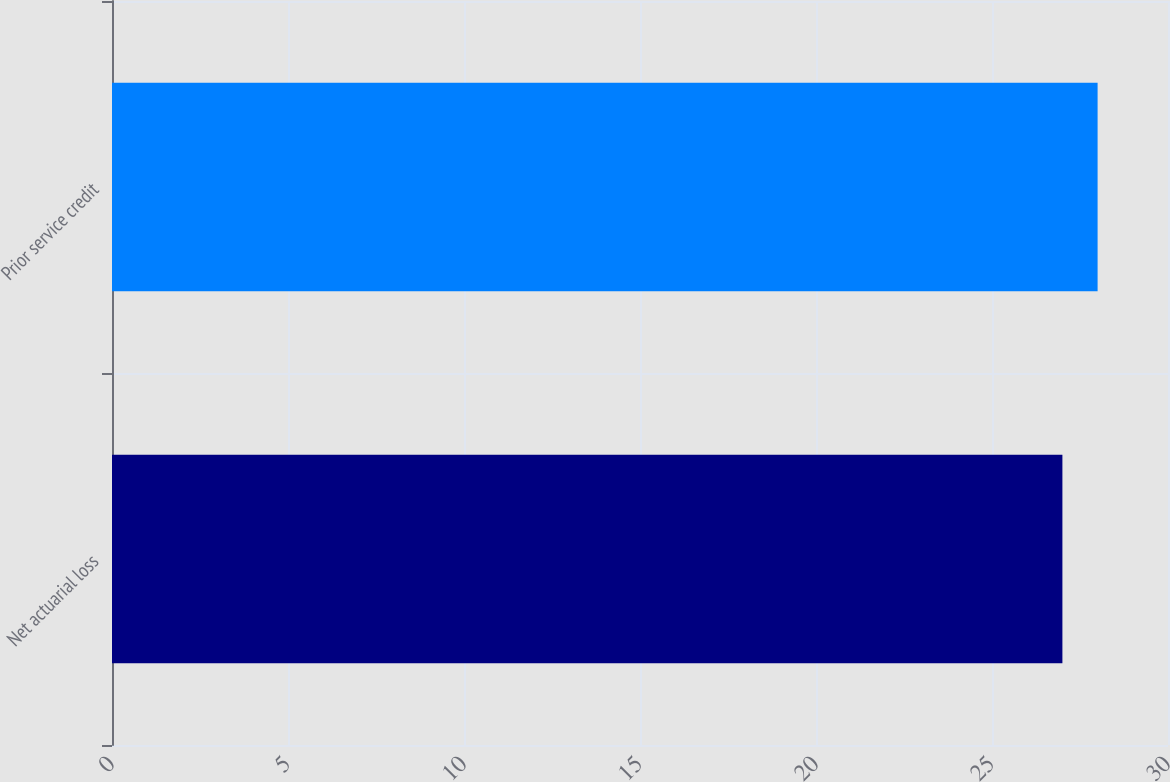Convert chart to OTSL. <chart><loc_0><loc_0><loc_500><loc_500><bar_chart><fcel>Net actuarial loss<fcel>Prior service credit<nl><fcel>27<fcel>28<nl></chart> 